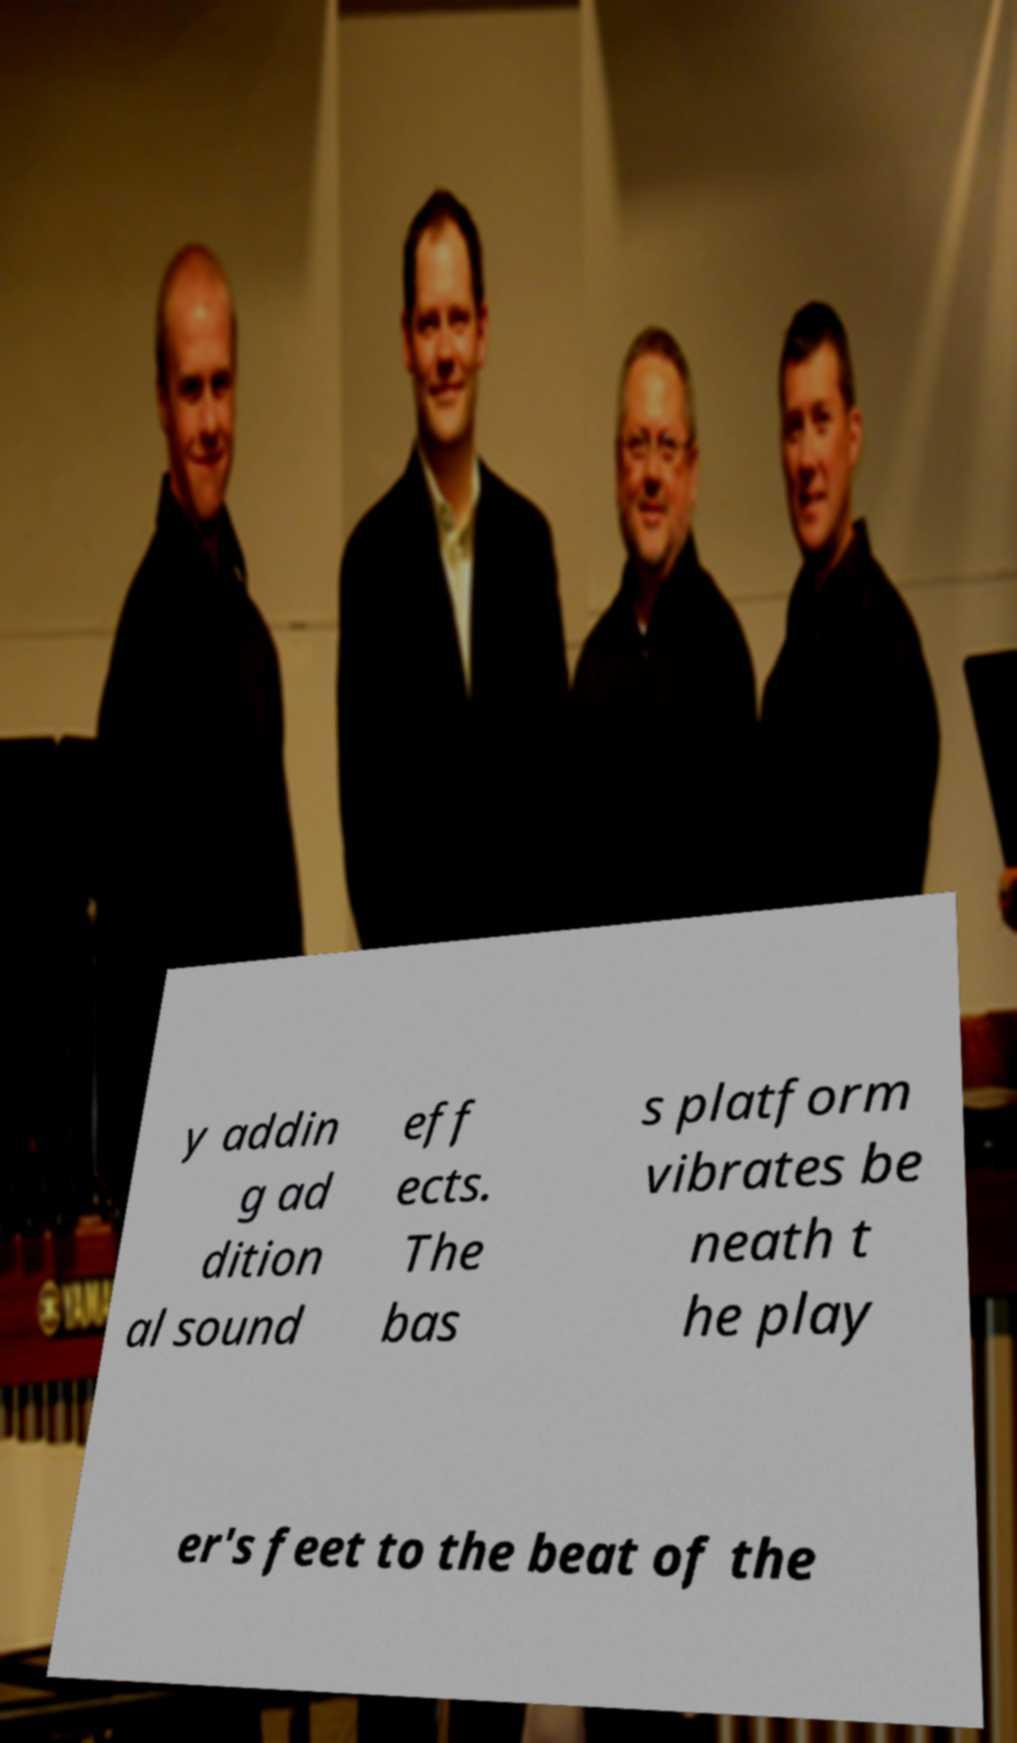Please read and relay the text visible in this image. What does it say? y addin g ad dition al sound eff ects. The bas s platform vibrates be neath t he play er's feet to the beat of the 